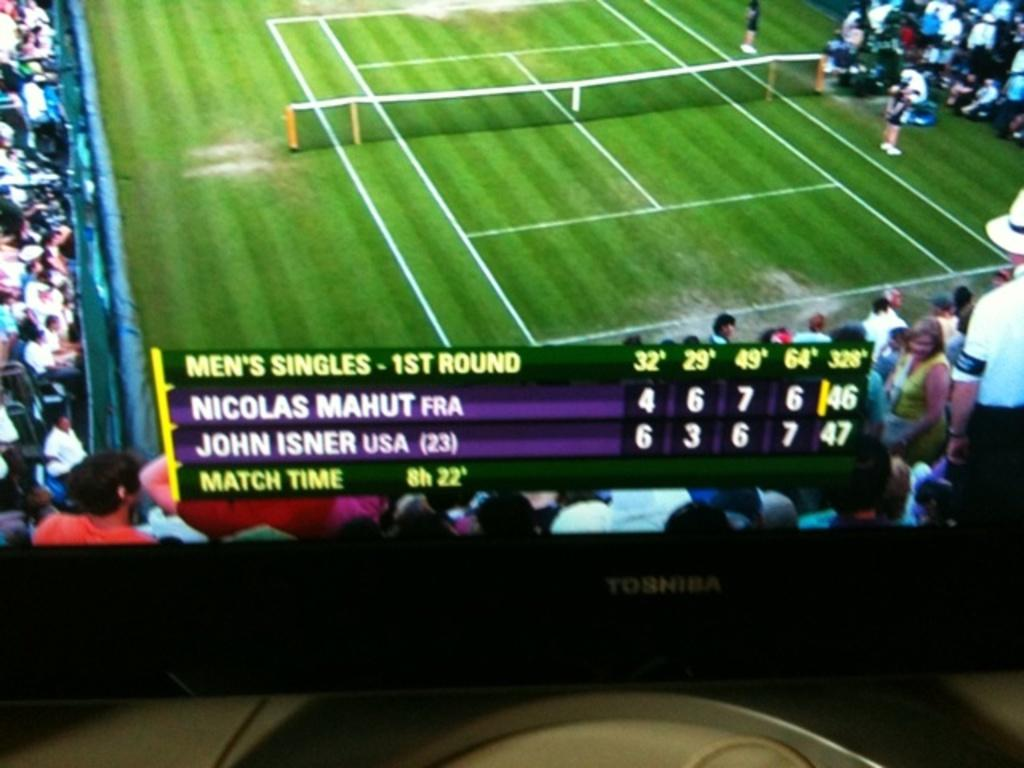<image>
Give a short and clear explanation of the subsequent image. A TV that says Toshiba on the front is showing a tennis match. 